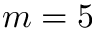Convert formula to latex. <formula><loc_0><loc_0><loc_500><loc_500>m = 5</formula> 